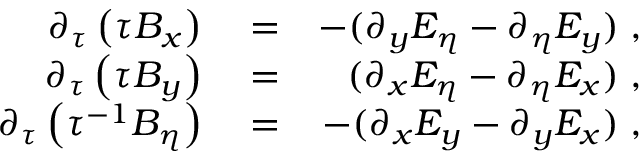<formula> <loc_0><loc_0><loc_500><loc_500>\begin{array} { r l r } { \partial _ { \tau } \left ( \tau B _ { x } \right ) } & = } & { - ( \partial _ { y } E _ { \eta } - \partial _ { \eta } E _ { y } ) \, , } \\ { \partial _ { \tau } \left ( \tau B _ { y } \right ) } & = } & { ( \partial _ { x } E _ { \eta } - \partial _ { \eta } E _ { x } ) \, , } \\ { \partial _ { \tau } \left ( \tau ^ { - 1 } B _ { \eta } \right ) } & = } & { - ( \partial _ { x } E _ { y } - \partial _ { y } E _ { x } ) \, , } \end{array}</formula> 